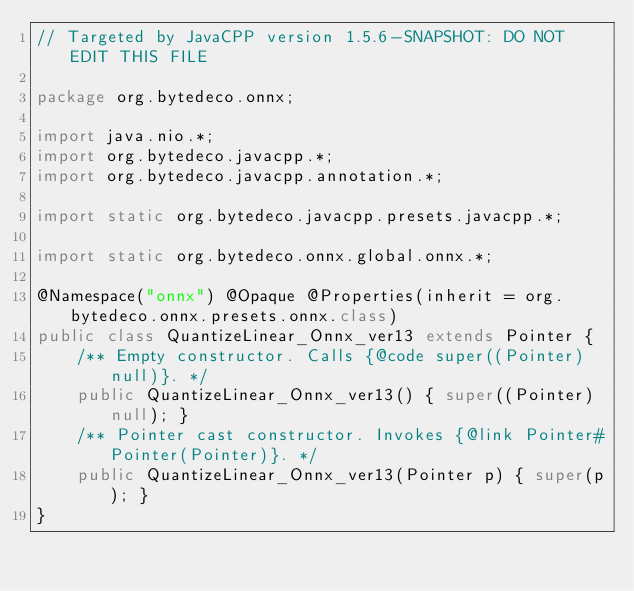<code> <loc_0><loc_0><loc_500><loc_500><_Java_>// Targeted by JavaCPP version 1.5.6-SNAPSHOT: DO NOT EDIT THIS FILE

package org.bytedeco.onnx;

import java.nio.*;
import org.bytedeco.javacpp.*;
import org.bytedeco.javacpp.annotation.*;

import static org.bytedeco.javacpp.presets.javacpp.*;

import static org.bytedeco.onnx.global.onnx.*;

@Namespace("onnx") @Opaque @Properties(inherit = org.bytedeco.onnx.presets.onnx.class)
public class QuantizeLinear_Onnx_ver13 extends Pointer {
    /** Empty constructor. Calls {@code super((Pointer)null)}. */
    public QuantizeLinear_Onnx_ver13() { super((Pointer)null); }
    /** Pointer cast constructor. Invokes {@link Pointer#Pointer(Pointer)}. */
    public QuantizeLinear_Onnx_ver13(Pointer p) { super(p); }
}
</code> 